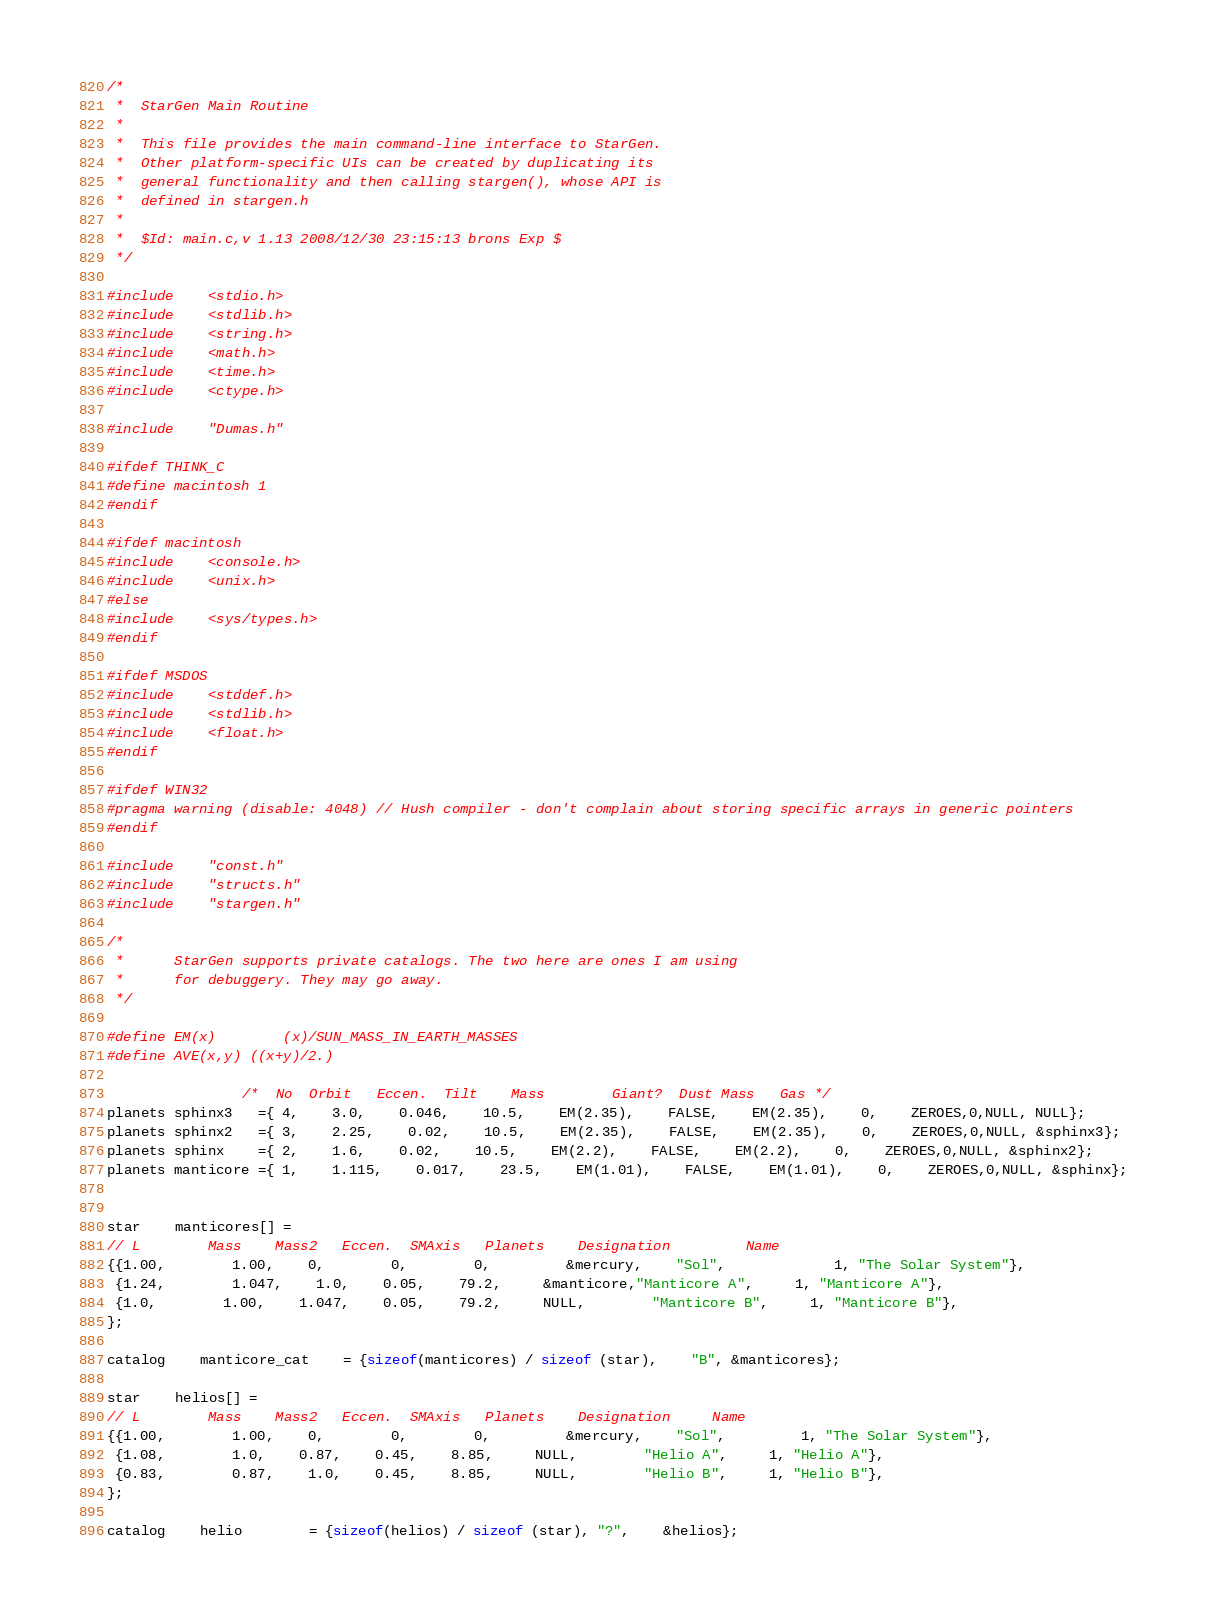<code> <loc_0><loc_0><loc_500><loc_500><_C_>/*
 *	StarGen Main Routine
 *
 *	This file provides the main command-line interface to StarGen.
 *	Other platform-specific UIs can be created by duplicating its
 *	general functionality and then calling stargen(), whose API is
 *	defined in stargen.h
 *
 *	$Id: main.c,v 1.13 2008/12/30 23:15:13 brons Exp $
 */

#include	<stdio.h>
#include	<stdlib.h>
#include	<string.h>
#include	<math.h>
#include	<time.h>
#include	<ctype.h>

#include	"Dumas.h"

#ifdef THINK_C
#define macintosh 1
#endif

#ifdef macintosh
#include	<console.h>
#include	<unix.h>
#else
#include	<sys/types.h>
#endif

#ifdef MSDOS
#include	<stddef.h>
#include	<stdlib.h>
#include	<float.h>
#endif

#ifdef WIN32
#pragma warning (disable: 4048) // Hush compiler - don't complain about storing specific arrays in generic pointers
#endif

#include	"const.h"
#include	"structs.h"
#include	"stargen.h"

/*
 *		StarGen supports private catalogs. The two here are ones I am using
 *		for debuggery. They may go away.
 */

#define EM(x)		(x)/SUN_MASS_IN_EARTH_MASSES
#define AVE(x,y)	((x+y)/2.)

				/*  No 	Orbit	Eccen. 	Tilt	Mass		Giant?	Dust Mass	Gas */
planets sphinx3   ={ 4,	3.0,	0.046,	10.5,	EM(2.35),	FALSE,	EM(2.35),	0, 	ZEROES,0,NULL, NULL};
planets sphinx2   ={ 3,	2.25,	0.02,	10.5,	EM(2.35),	FALSE,	EM(2.35),	0, 	ZEROES,0,NULL, &sphinx3};
planets sphinx    ={ 2,	1.6,	0.02,	10.5,	EM(2.2),	FALSE,	EM(2.2),	0, 	ZEROES,0,NULL, &sphinx2};
planets manticore ={ 1,	1.115,	0.017,	23.5,	EM(1.01),	FALSE,	EM(1.01),	0, 	ZEROES,0,NULL, &sphinx};


star	manticores[] = 
// L		Mass	Mass2	Eccen.	SMAxis	 Planets	Designation			Name
{{1.00,		1.00,	0,		0,		0,		 &mercury,	"Sol",		 	 1, "The Solar System"},
 {1.24,		1.047,	1.0,	0.05,	79.2,	 &manticore,"Manticore A",	 1, "Manticore A"},
 {1.0,		1.00,	1.047,	0.05,	79.2,	 NULL,		"Manticore B",	 1, "Manticore B"},
};

catalog	manticore_cat	= {sizeof(manticores) / sizeof (star),	"B", &manticores};

star	helios[] = 
// L		Mass	Mass2	Eccen.	SMAxis	 Planets	Designation		Name
{{1.00,		1.00,	0,		0,		0,		 &mercury,	"Sol",		 1, "The Solar System"},
 {1.08,		1.0,	0.87,	0.45,	8.85,	 NULL,		"Helio A",	 1, "Helio A"},
 {0.83,		0.87,	1.0,	0.45,	8.85,	 NULL,		"Helio B",	 1, "Helio B"},
};

catalog	helio		= {sizeof(helios) / sizeof (star), "?",	&helios};
</code> 